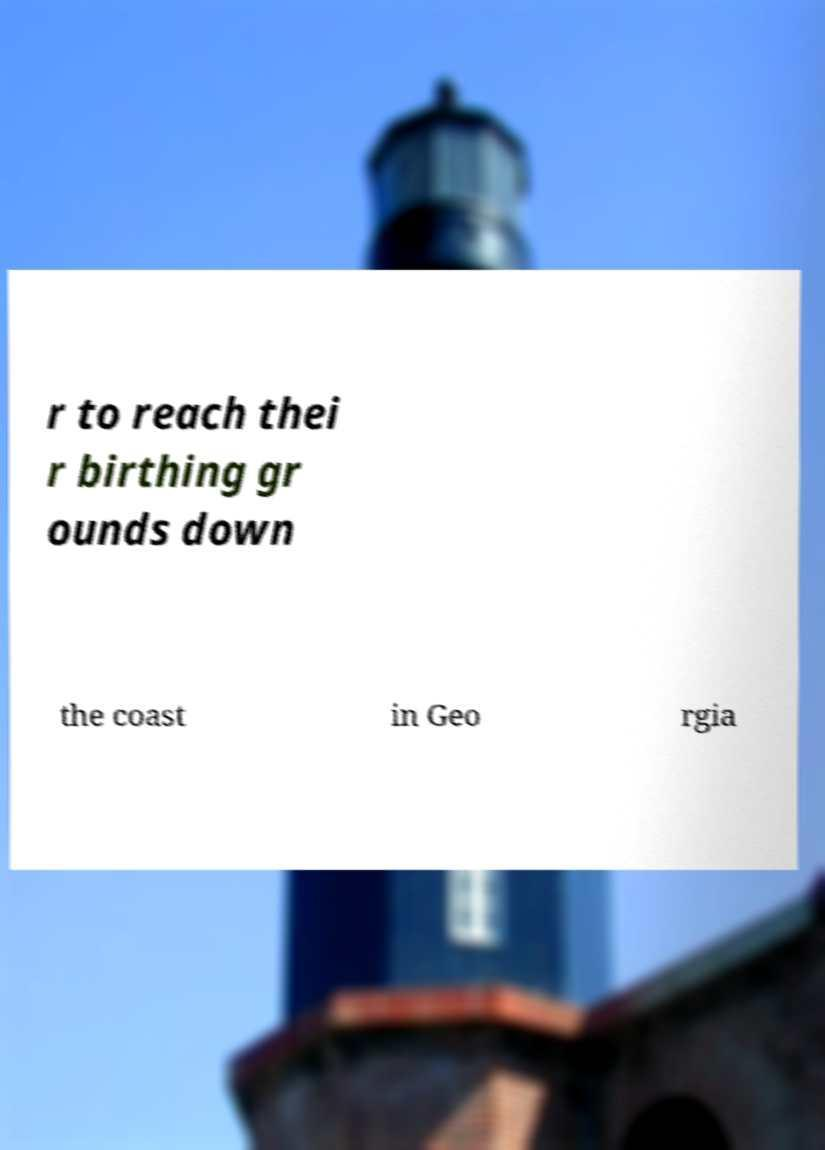There's text embedded in this image that I need extracted. Can you transcribe it verbatim? r to reach thei r birthing gr ounds down the coast in Geo rgia 